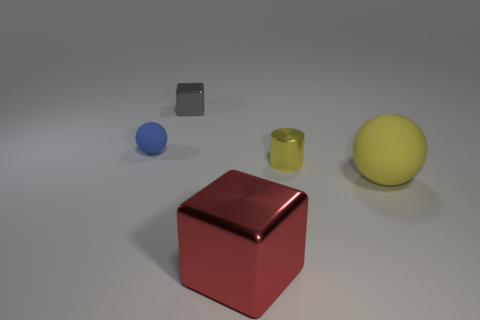There is a large thing that is the same material as the small gray object; what shape is it?
Your response must be concise. Cube. Are there any tiny gray cubes behind the small shiny object behind the blue sphere?
Provide a succinct answer. No. What size is the yellow matte sphere?
Give a very brief answer. Large. What number of things are either matte things or cylinders?
Make the answer very short. 3. Do the block on the right side of the tiny gray cube and the ball in front of the small matte thing have the same material?
Your answer should be compact. No. The other large thing that is the same material as the blue thing is what color?
Ensure brevity in your answer.  Yellow. What number of blue things have the same size as the gray thing?
Provide a succinct answer. 1. What number of other things are there of the same color as the big rubber sphere?
Give a very brief answer. 1. Does the matte thing to the right of the small gray thing have the same shape as the rubber object left of the metal cylinder?
Give a very brief answer. Yes. There is a gray metallic thing that is the same size as the blue rubber thing; what is its shape?
Ensure brevity in your answer.  Cube. 